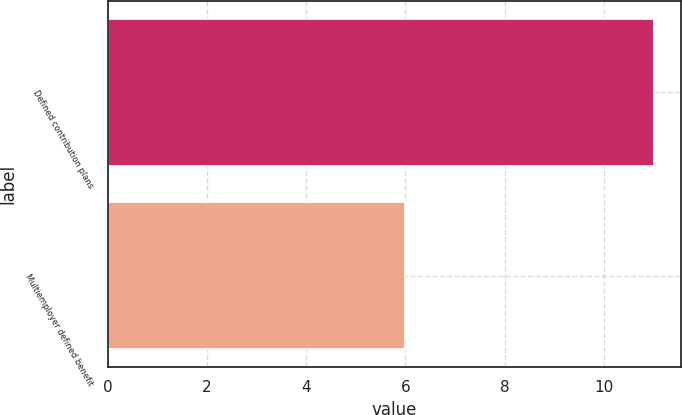Convert chart to OTSL. <chart><loc_0><loc_0><loc_500><loc_500><bar_chart><fcel>Defined contribution plans<fcel>Multiemployer defined benefit<nl><fcel>11<fcel>6<nl></chart> 